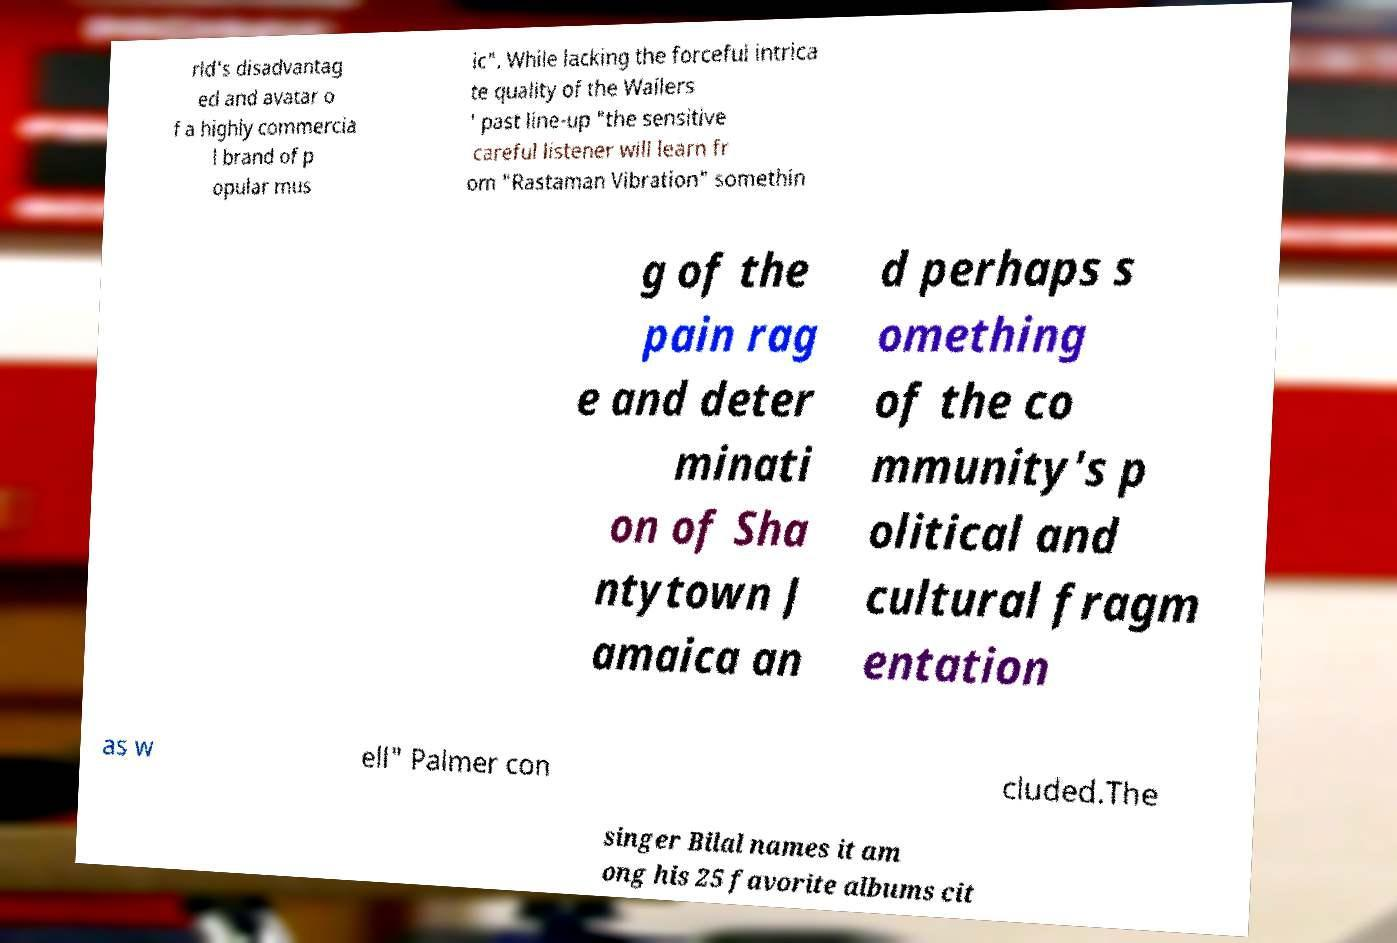Could you extract and type out the text from this image? rld's disadvantag ed and avatar o f a highly commercia l brand of p opular mus ic". While lacking the forceful intrica te quality of the Wailers ' past line-up "the sensitive careful listener will learn fr om "Rastaman Vibration" somethin g of the pain rag e and deter minati on of Sha ntytown J amaica an d perhaps s omething of the co mmunity's p olitical and cultural fragm entation as w ell" Palmer con cluded.The singer Bilal names it am ong his 25 favorite albums cit 